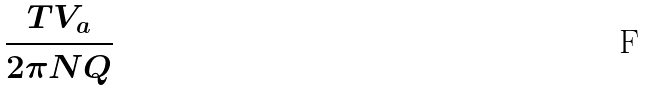<formula> <loc_0><loc_0><loc_500><loc_500>\frac { T V _ { a } } { 2 \pi N Q }</formula> 